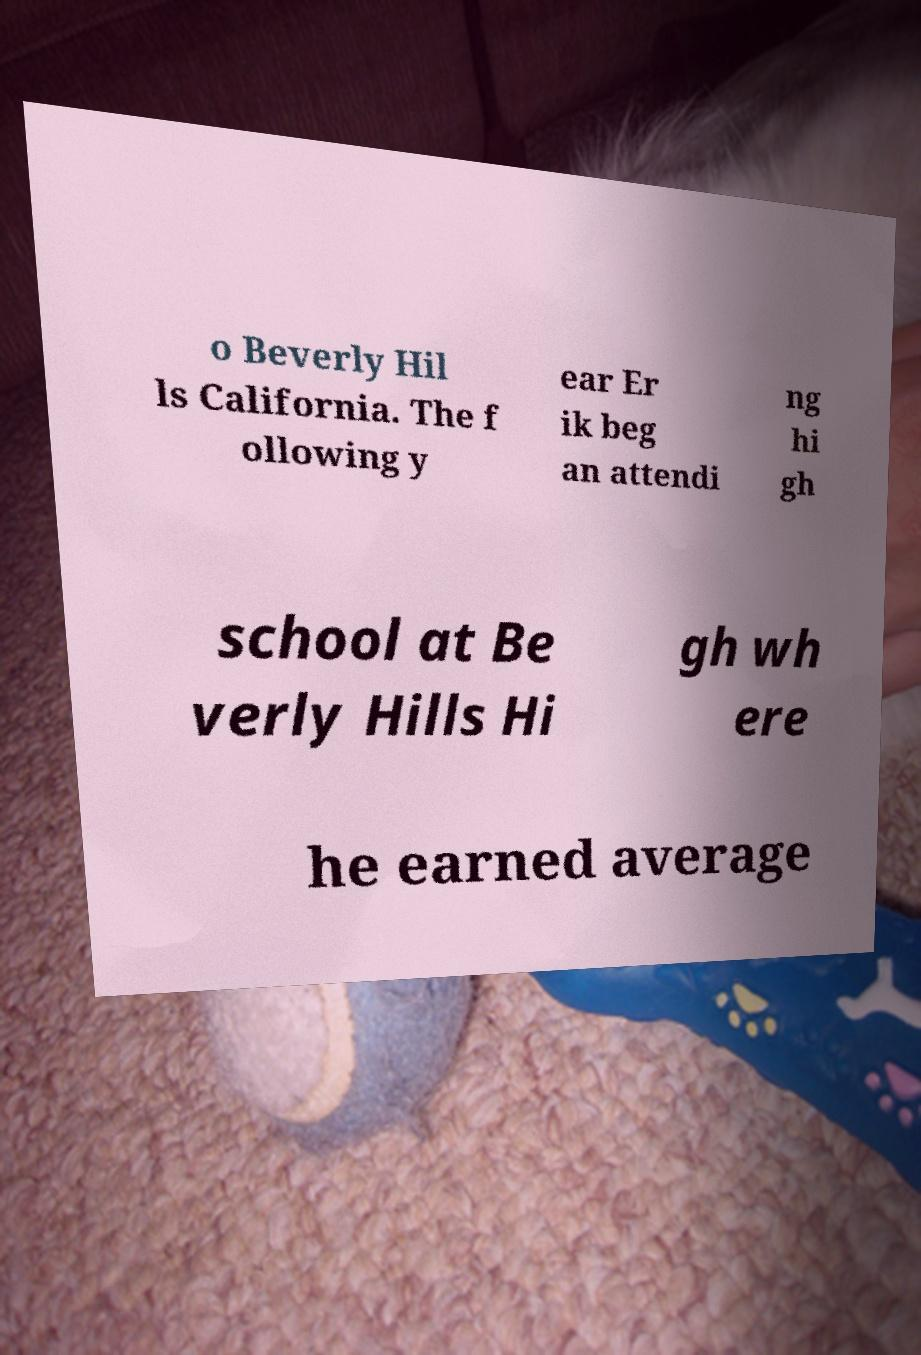Please read and relay the text visible in this image. What does it say? o Beverly Hil ls California. The f ollowing y ear Er ik beg an attendi ng hi gh school at Be verly Hills Hi gh wh ere he earned average 